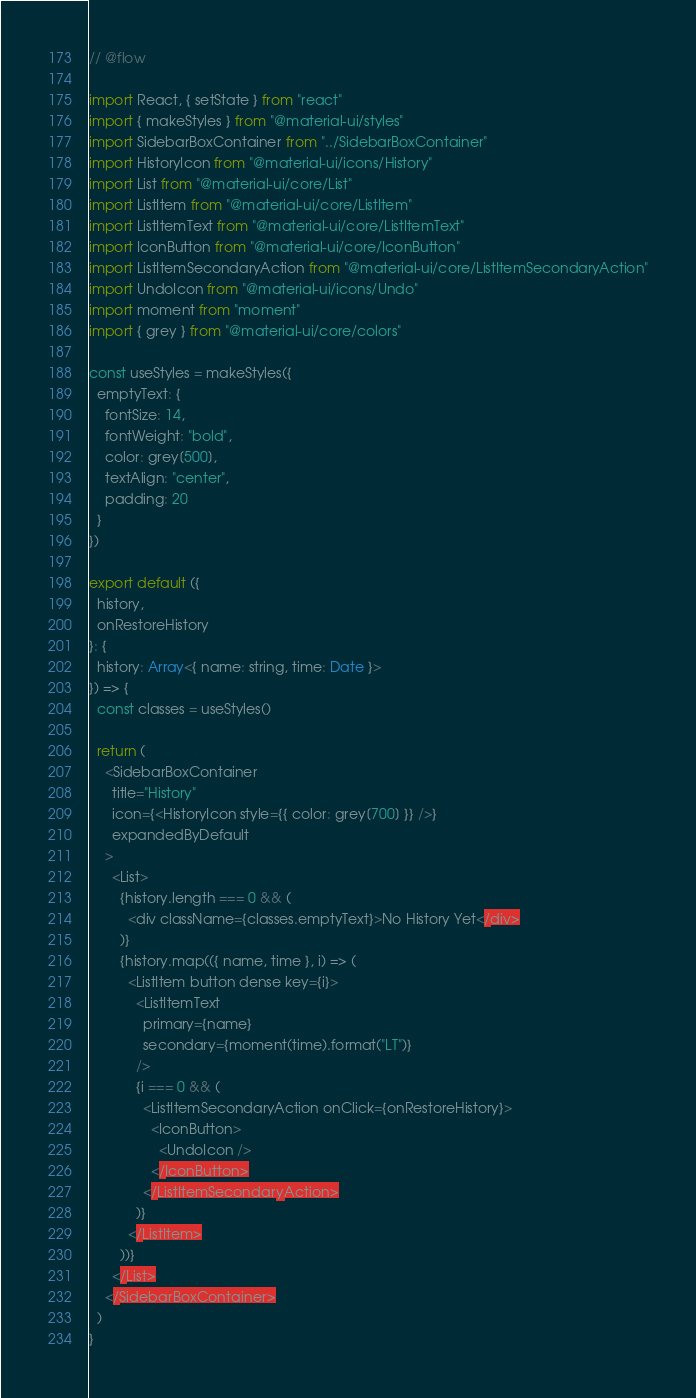<code> <loc_0><loc_0><loc_500><loc_500><_JavaScript_>// @flow

import React, { setState } from "react"
import { makeStyles } from "@material-ui/styles"
import SidebarBoxContainer from "../SidebarBoxContainer"
import HistoryIcon from "@material-ui/icons/History"
import List from "@material-ui/core/List"
import ListItem from "@material-ui/core/ListItem"
import ListItemText from "@material-ui/core/ListItemText"
import IconButton from "@material-ui/core/IconButton"
import ListItemSecondaryAction from "@material-ui/core/ListItemSecondaryAction"
import UndoIcon from "@material-ui/icons/Undo"
import moment from "moment"
import { grey } from "@material-ui/core/colors"

const useStyles = makeStyles({
  emptyText: {
    fontSize: 14,
    fontWeight: "bold",
    color: grey[500],
    textAlign: "center",
    padding: 20
  }
})

export default ({
  history,
  onRestoreHistory
}: {
  history: Array<{ name: string, time: Date }>
}) => {
  const classes = useStyles()

  return (
    <SidebarBoxContainer
      title="History"
      icon={<HistoryIcon style={{ color: grey[700] }} />}
      expandedByDefault
    >
      <List>
        {history.length === 0 && (
          <div className={classes.emptyText}>No History Yet</div>
        )}
        {history.map(({ name, time }, i) => (
          <ListItem button dense key={i}>
            <ListItemText
              primary={name}
              secondary={moment(time).format("LT")}
            />
            {i === 0 && (
              <ListItemSecondaryAction onClick={onRestoreHistory}>
                <IconButton>
                  <UndoIcon />
                </IconButton>
              </ListItemSecondaryAction>
            )}
          </ListItem>
        ))}
      </List>
    </SidebarBoxContainer>
  )
}
</code> 